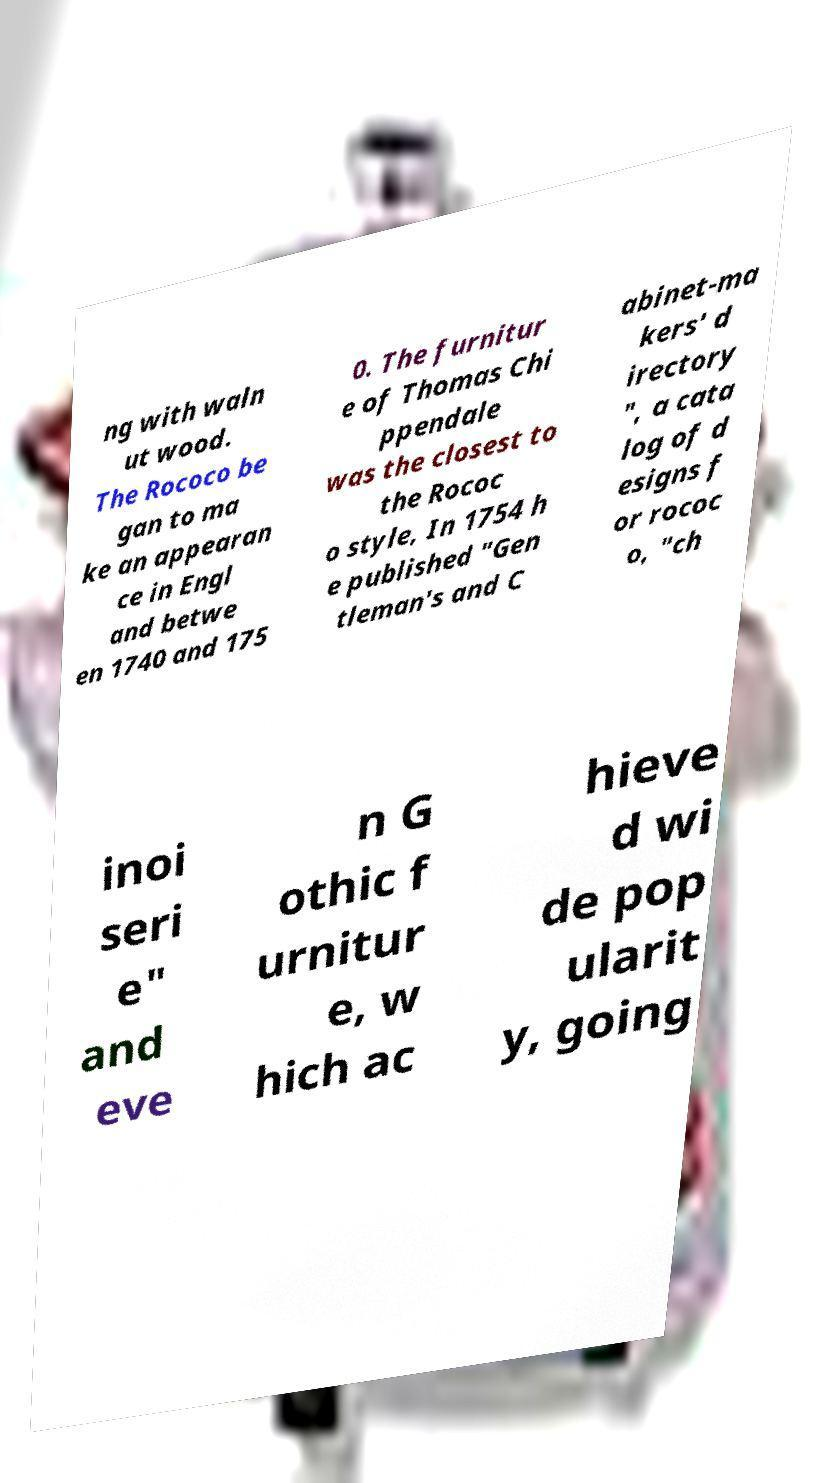I need the written content from this picture converted into text. Can you do that? ng with waln ut wood. The Rococo be gan to ma ke an appearan ce in Engl and betwe en 1740 and 175 0. The furnitur e of Thomas Chi ppendale was the closest to the Rococ o style, In 1754 h e published "Gen tleman's and C abinet-ma kers' d irectory ", a cata log of d esigns f or rococ o, "ch inoi seri e" and eve n G othic f urnitur e, w hich ac hieve d wi de pop ularit y, going 